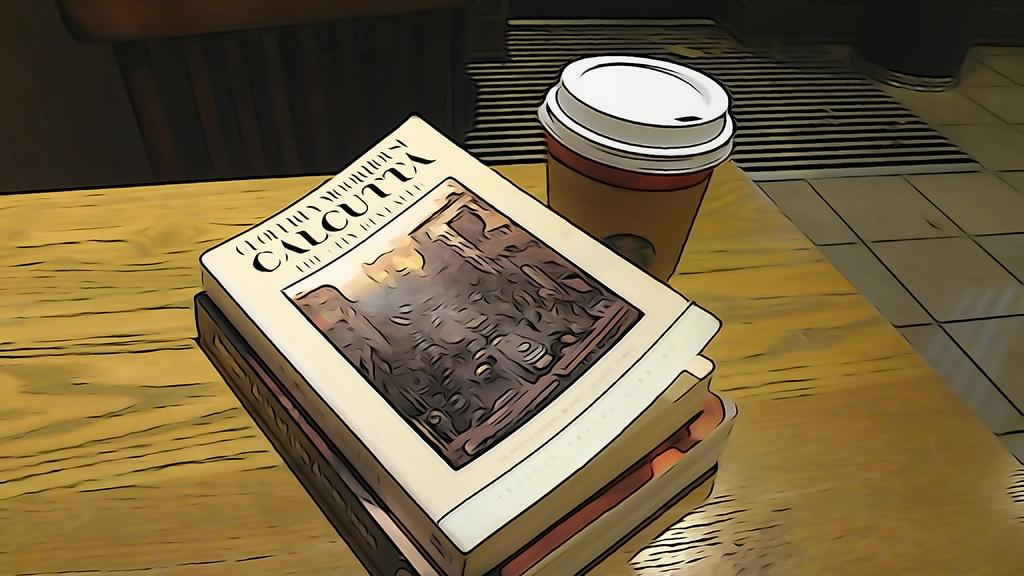<image>
Provide a brief description of the given image. Calcutta book on a table beside a starbucks coffee cup. 